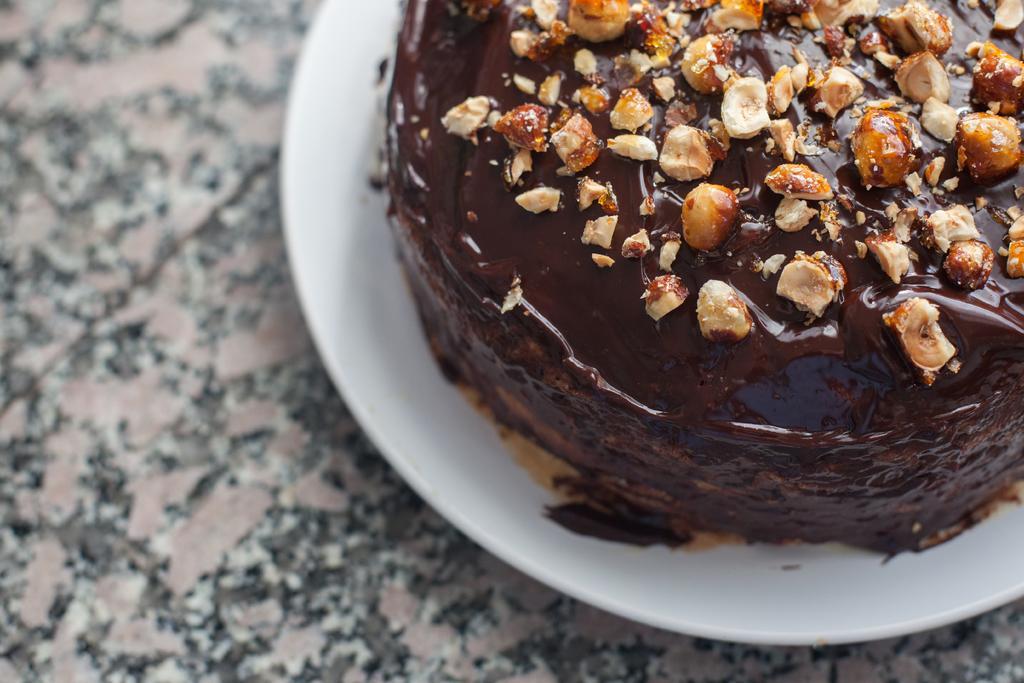Could you give a brief overview of what you see in this image? In this image there is a plate on the floor, there is food on the plate. 